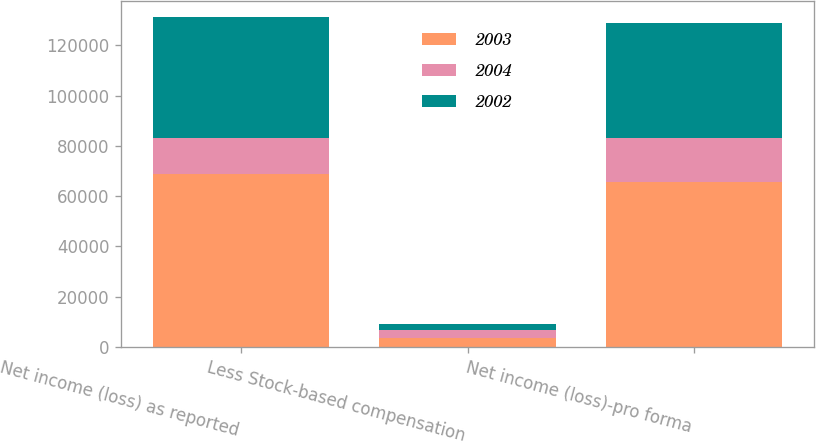Convert chart to OTSL. <chart><loc_0><loc_0><loc_500><loc_500><stacked_bar_chart><ecel><fcel>Net income (loss) as reported<fcel>Less Stock-based compensation<fcel>Net income (loss)-pro forma<nl><fcel>2003<fcel>68730<fcel>3583<fcel>65558<nl><fcel>2004<fcel>14358<fcel>3194<fcel>17429<nl><fcel>2002<fcel>48179<fcel>2315<fcel>45864<nl></chart> 